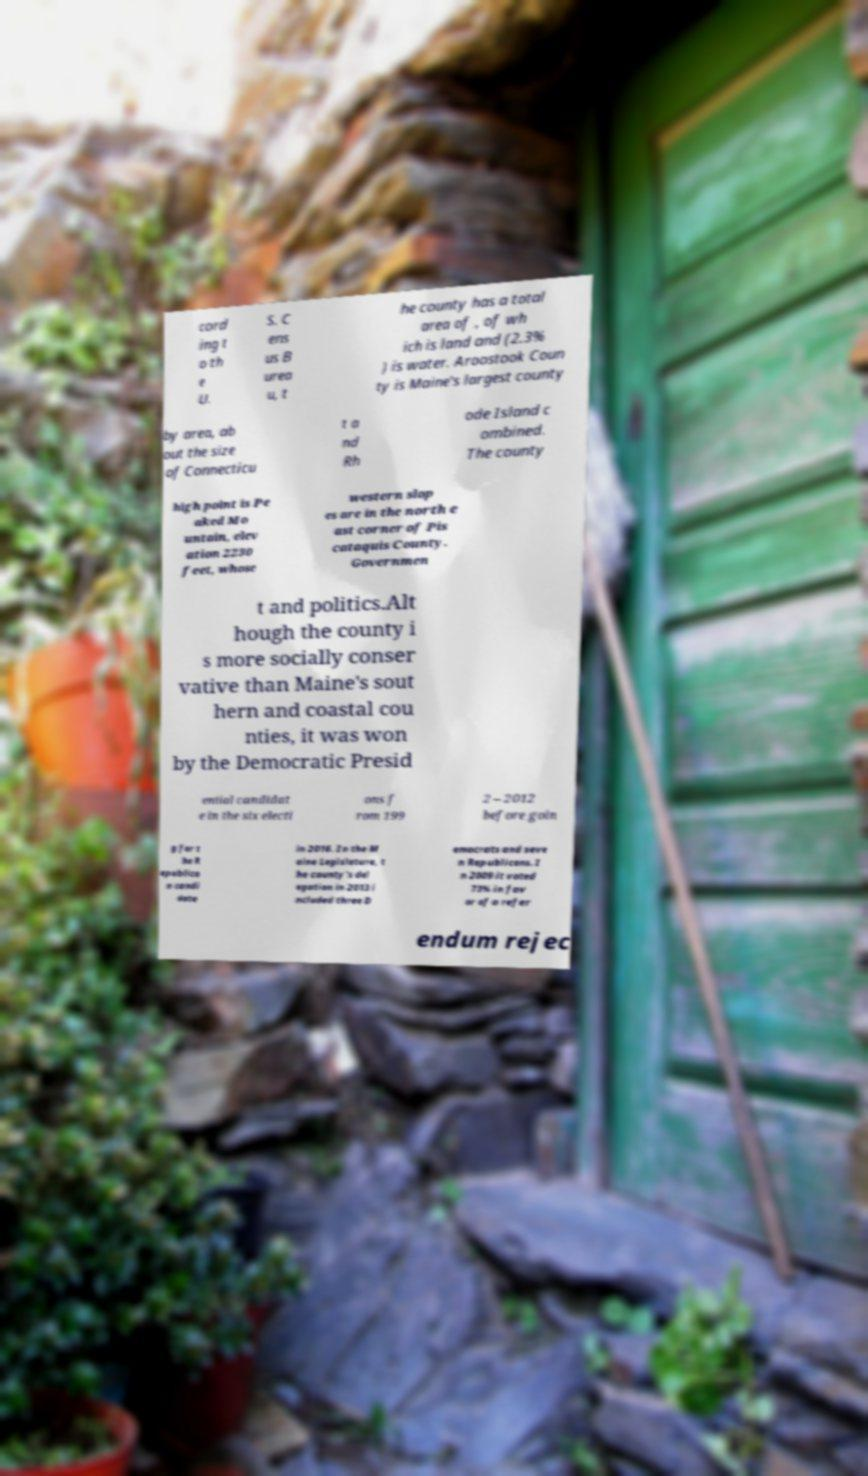What messages or text are displayed in this image? I need them in a readable, typed format. cord ing t o th e U. S. C ens us B urea u, t he county has a total area of , of wh ich is land and (2.3% ) is water. Aroostook Coun ty is Maine's largest county by area, ab out the size of Connecticu t a nd Rh ode Island c ombined. The county high point is Pe aked Mo untain, elev ation 2230 feet, whose western slop es are in the north e ast corner of Pis cataquis County. Governmen t and politics.Alt hough the county i s more socially conser vative than Maine's sout hern and coastal cou nties, it was won by the Democratic Presid ential candidat e in the six electi ons f rom 199 2 – 2012 before goin g for t he R epublica n candi date in 2016. In the M aine Legislature, t he county's del egation in 2013 i ncluded three D emocrats and seve n Republicans. I n 2009 it voted 73% in fav or of a refer endum rejec 